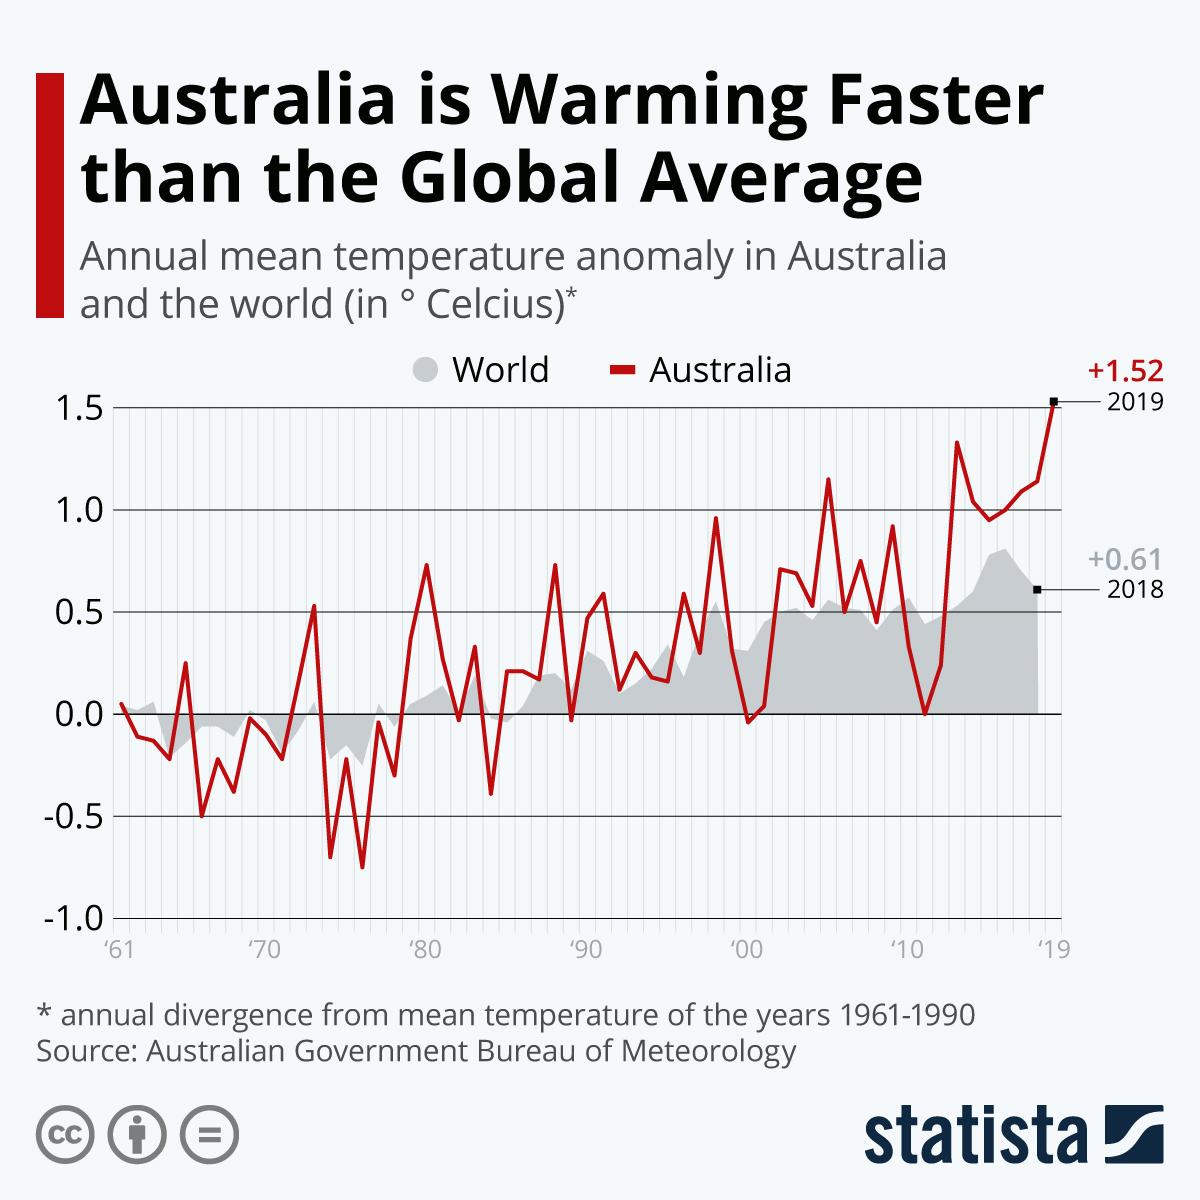Draw attention to some important aspects in this diagram. The highest annual mean temperature in the world was +0.61 degrees Celsius. The temperature anomaly in Australia occurred in 2019. The highest annual mean temperature in Australia was +1.52 degrees Celsius. 